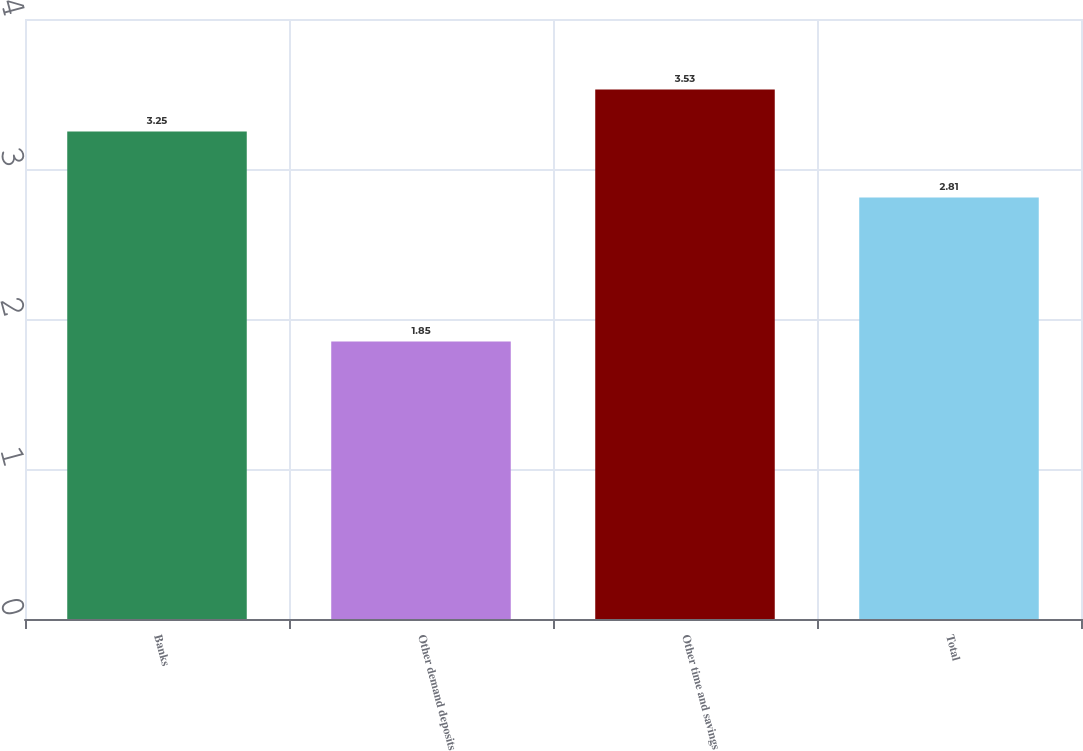Convert chart to OTSL. <chart><loc_0><loc_0><loc_500><loc_500><bar_chart><fcel>Banks<fcel>Other demand deposits<fcel>Other time and savings<fcel>Total<nl><fcel>3.25<fcel>1.85<fcel>3.53<fcel>2.81<nl></chart> 